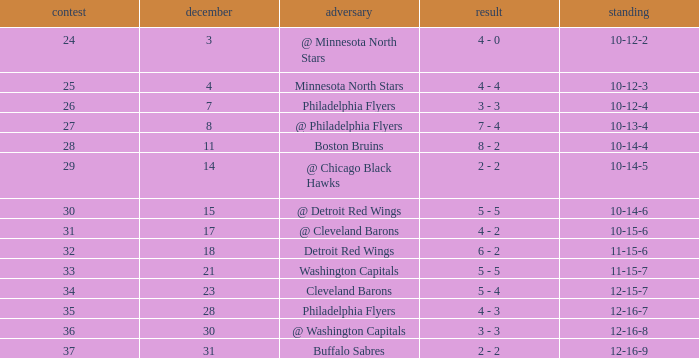What is Opponent, when Game is "37"? Buffalo Sabres. 